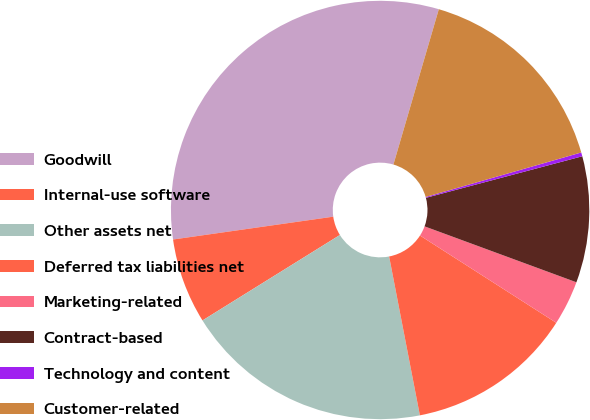Convert chart. <chart><loc_0><loc_0><loc_500><loc_500><pie_chart><fcel>Goodwill<fcel>Internal-use software<fcel>Other assets net<fcel>Deferred tax liabilities net<fcel>Marketing-related<fcel>Contract-based<fcel>Technology and content<fcel>Customer-related<nl><fcel>31.78%<fcel>6.6%<fcel>19.19%<fcel>12.89%<fcel>3.45%<fcel>9.75%<fcel>0.3%<fcel>16.04%<nl></chart> 